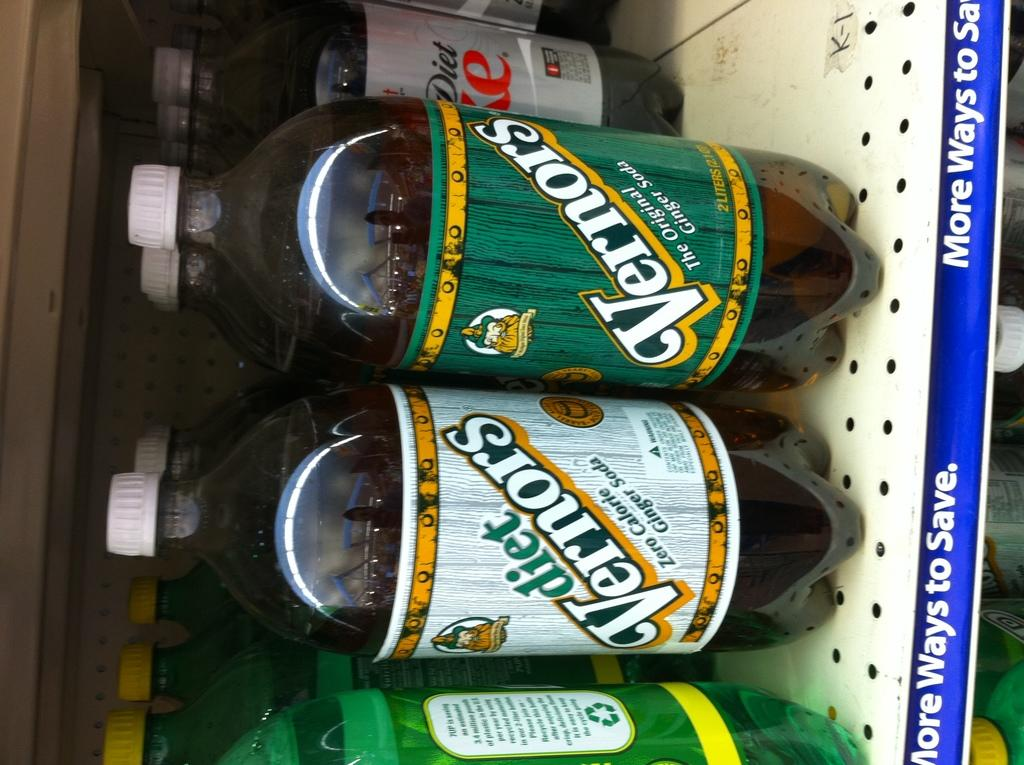<image>
Give a short and clear explanation of the subsequent image. Some bottles of Vernors and Diet Vernors are on a shelf in a store. 